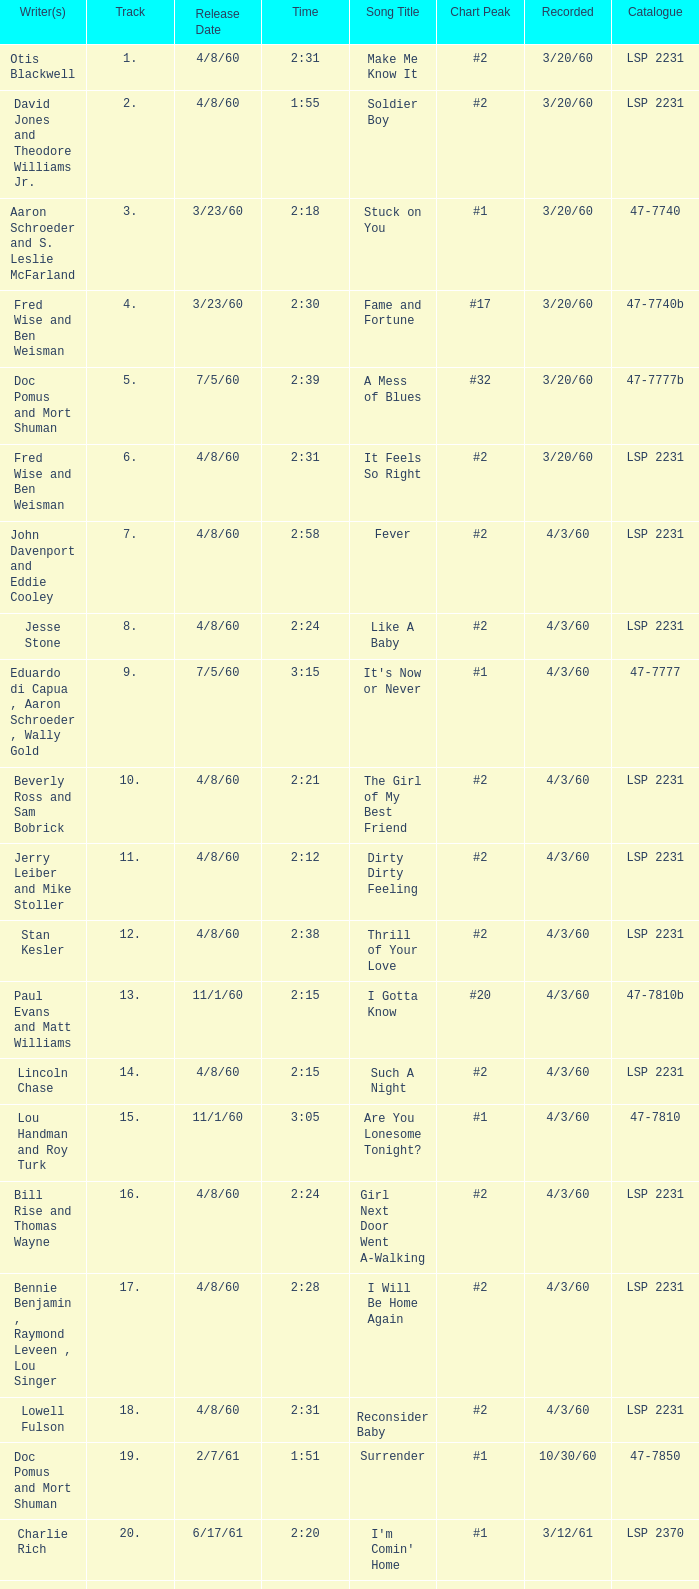What is the time of songs that have the writer Aaron Schroeder and Wally Gold? 1:50. 